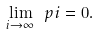<formula> <loc_0><loc_0><loc_500><loc_500>\lim _ { i \rightarrow \infty } \ p { i } = 0 .</formula> 